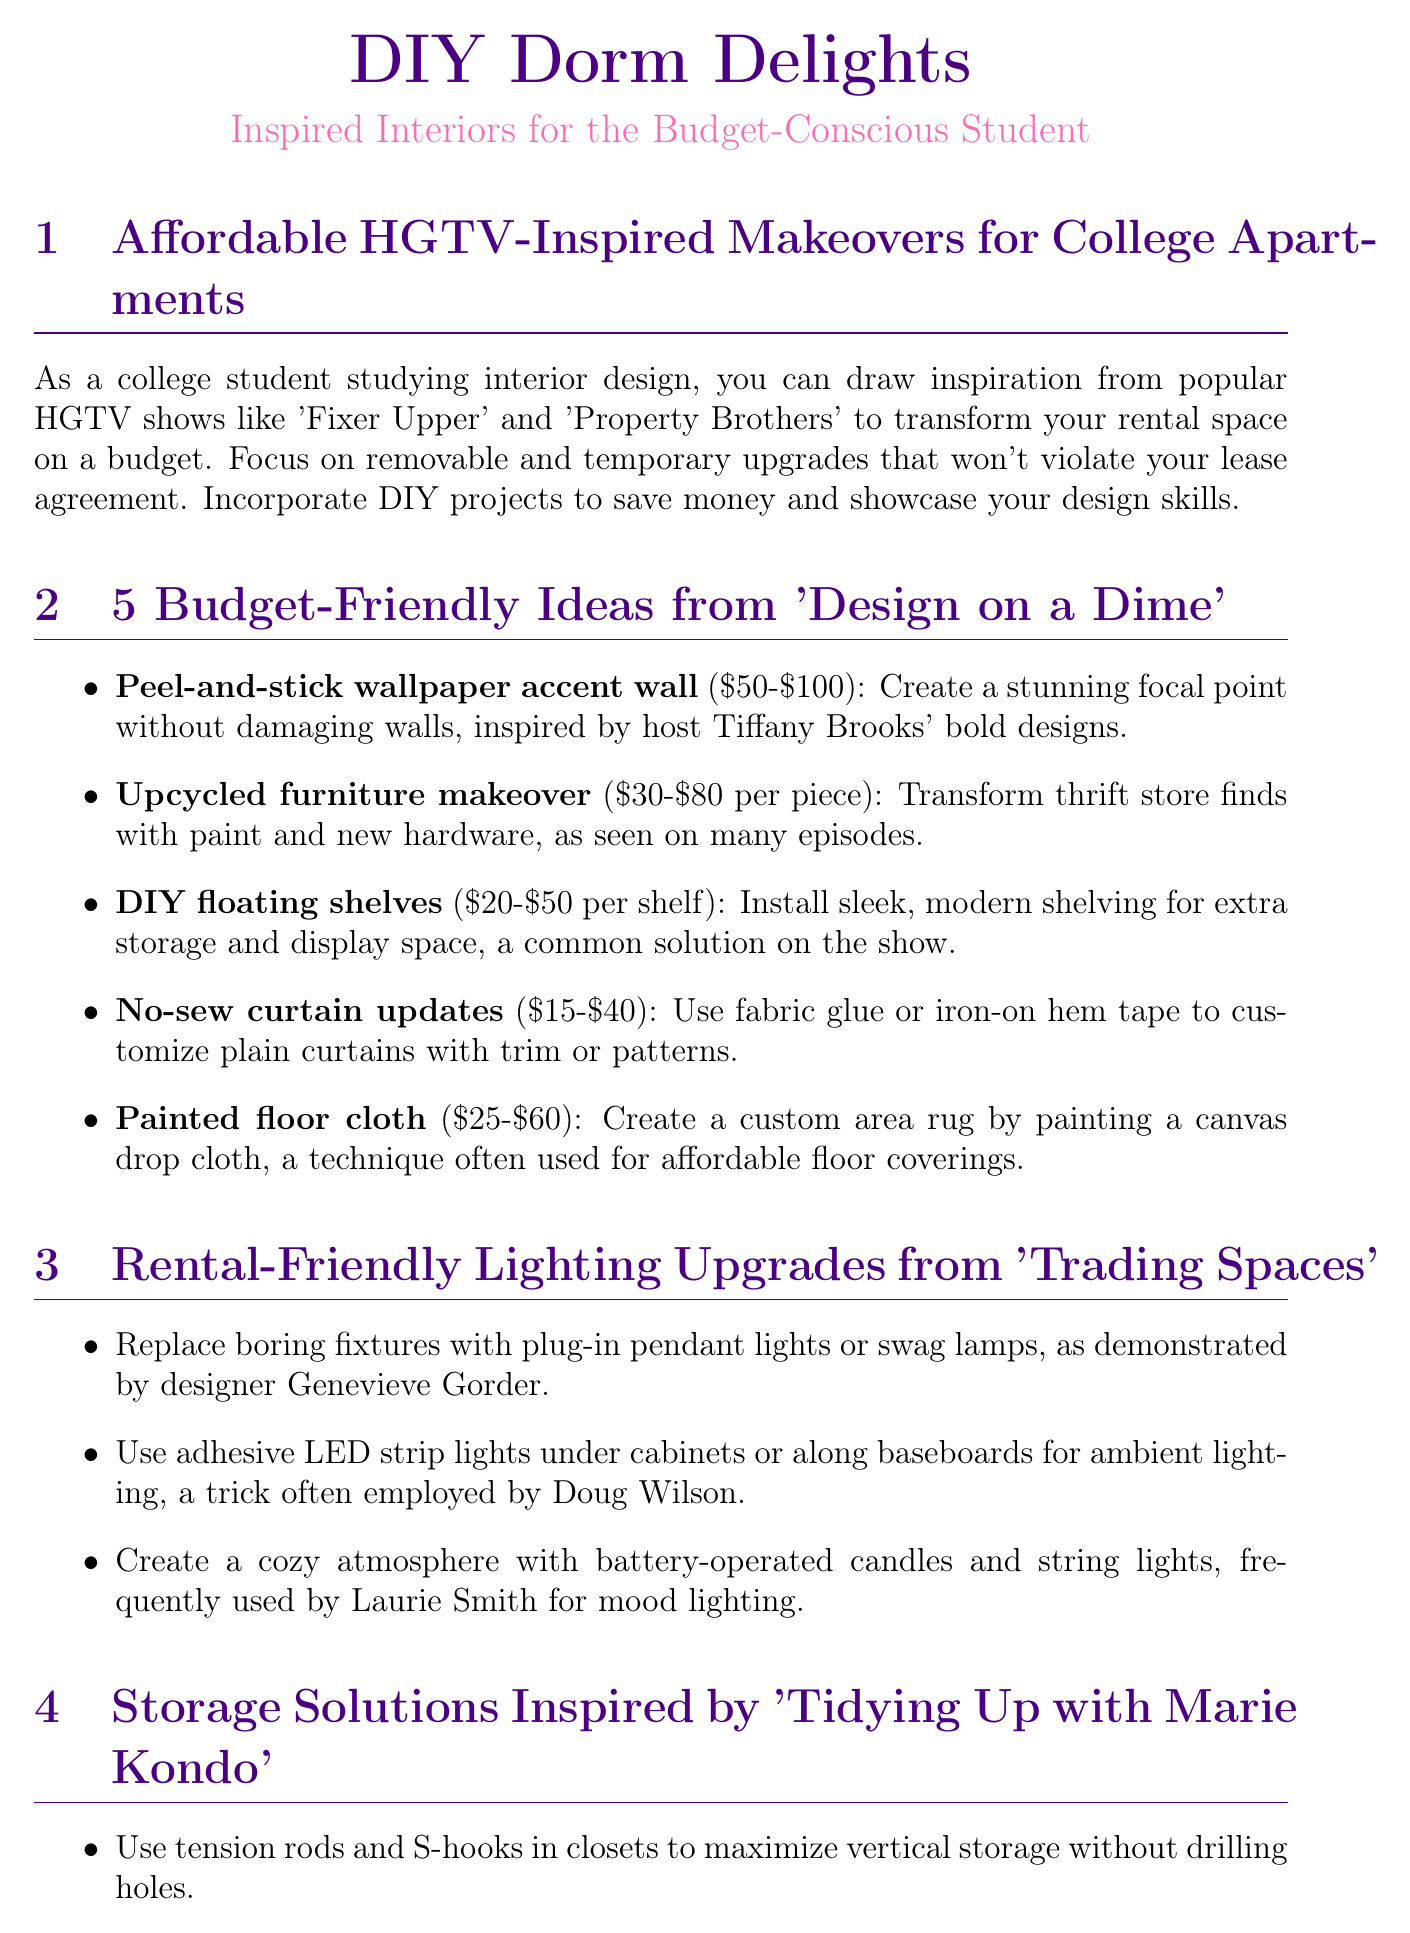What are some shows that inspire budget-friendly home improvements? The document mentions popular HGTV shows like 'Fixer Upper' and 'Property Brothers' as sources of inspiration for affordable makeovers.
Answer: 'Fixer Upper', 'Property Brothers' What is the estimated cost for a peel-and-stick wallpaper accent wall? The estimated cost for this project, as listed in the document, ranges between $50 to $100.
Answer: $50-$100 Which designer is mentioned in relation to lighting upgrades? Genevieve Gorder is mentioned in the document as the designer who demonstrates replacing boring fixtures with plug-in pendant lights or swag lamps.
Answer: Genevieve Gorder How can you maximize vertical storage in rental spaces? The document suggests using tension rods and S-hooks in closets to achieve vertical storage without drilling holes.
Answer: Tension rods and S-hooks What type of paint colors does the 'Earthy Neutrals' palette include? The 'Earthy Neutrals' palette consists of colors such as Behr's Whisper White, Sherwin-Williams' Agreeable Gray, and Benjamin Moore's Aegean Teal.
Answer: Behr's Whisper White, Sherwin-Williams' Agreeable Gray, Benjamin Moore's Aegean Teal What is a DIY project inspired by 'Love It or List It'? The document describes a DIY project for a room divider inspired by 'Love It or List It'.
Answer: Room divider Which materials are mentioned for no-sew curtain updates? The document mentions using fabric glue or iron-on hem tape as materials for updating plain curtains without sewing.
Answer: Fabric glue, iron-on hem tape 